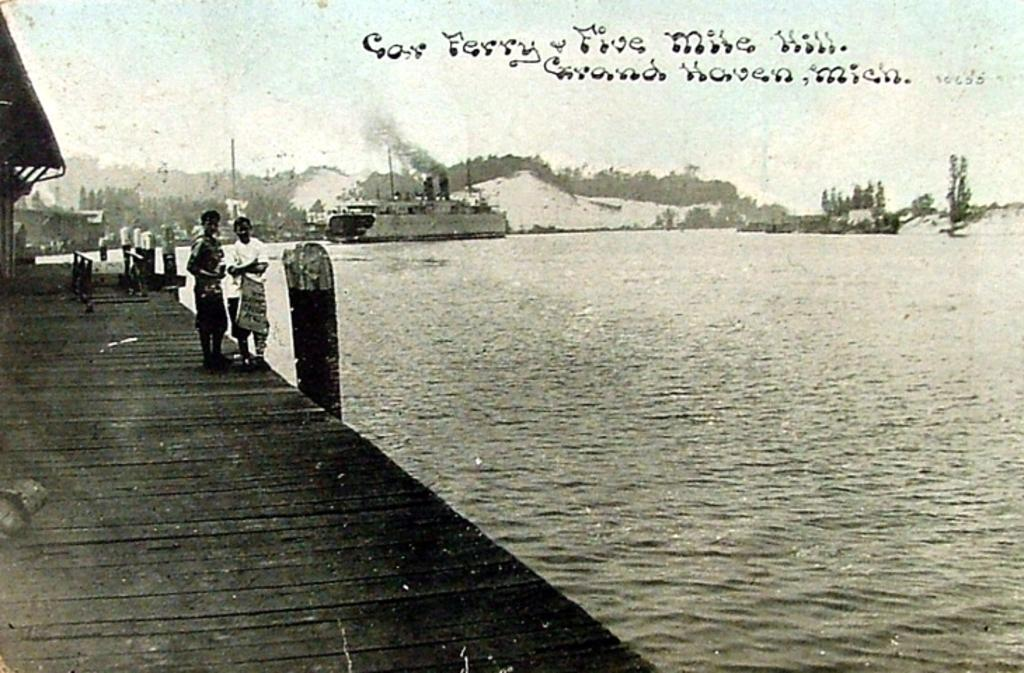What type of visual is the image? The image is a poster. How many people are depicted in the poster? There are two persons standing in the poster. What type of structures are shown in the poster? There are houses depicted in the poster. What natural element is present in the poster? There is water shown in the poster. What type of vegetation is present in the poster? Trees are present in the poster. What mode of transportation is shown on the water? There is a ship on the water in the poster. What part of the natural environment is visible in the poster? The sky is visible in the poster. What type of text is present on the poster? There are words on the poster. What type of animal is shown interacting with the ship in the poster? There is no animal shown interacting with the ship in the poster; only the ship, water, and other elements are present. What base is used for the houses in the poster? The houses in the poster do not have a visible base, as the focus is on the overall scene rather than the construction details of the houses. 